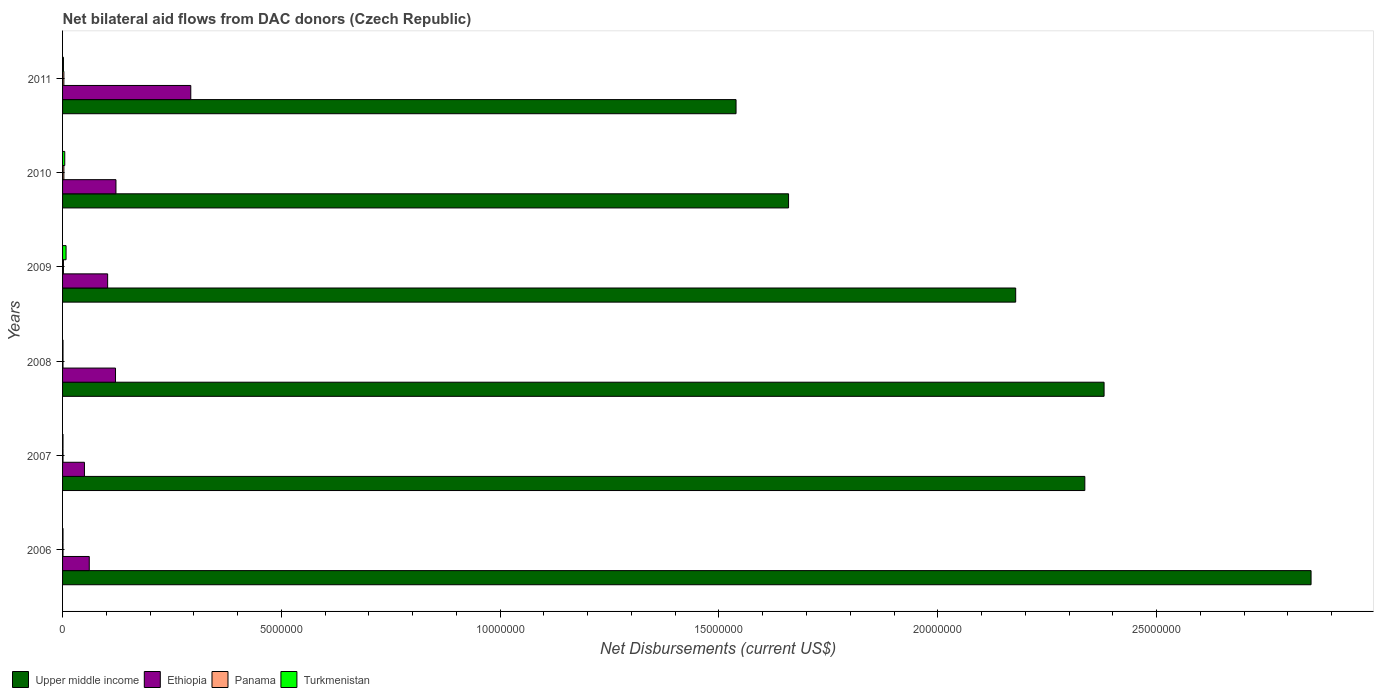How many different coloured bars are there?
Provide a succinct answer. 4. Are the number of bars on each tick of the Y-axis equal?
Ensure brevity in your answer.  Yes. How many bars are there on the 5th tick from the bottom?
Provide a succinct answer. 4. What is the label of the 3rd group of bars from the top?
Your response must be concise. 2009. In how many cases, is the number of bars for a given year not equal to the number of legend labels?
Provide a succinct answer. 0. What is the net bilateral aid flows in Upper middle income in 2011?
Provide a short and direct response. 1.54e+07. Across all years, what is the maximum net bilateral aid flows in Upper middle income?
Your answer should be compact. 2.85e+07. Across all years, what is the minimum net bilateral aid flows in Upper middle income?
Your answer should be compact. 1.54e+07. In which year was the net bilateral aid flows in Ethiopia maximum?
Provide a short and direct response. 2011. What is the total net bilateral aid flows in Ethiopia in the graph?
Give a very brief answer. 7.50e+06. What is the difference between the net bilateral aid flows in Turkmenistan in 2008 and the net bilateral aid flows in Upper middle income in 2007?
Your answer should be very brief. -2.34e+07. What is the average net bilateral aid flows in Upper middle income per year?
Make the answer very short. 2.16e+07. In the year 2006, what is the difference between the net bilateral aid flows in Turkmenistan and net bilateral aid flows in Ethiopia?
Your response must be concise. -6.00e+05. What is the ratio of the net bilateral aid flows in Panama in 2007 to that in 2008?
Your response must be concise. 1. Is the net bilateral aid flows in Upper middle income in 2009 less than that in 2010?
Ensure brevity in your answer.  No. Is the difference between the net bilateral aid flows in Turkmenistan in 2007 and 2011 greater than the difference between the net bilateral aid flows in Ethiopia in 2007 and 2011?
Your response must be concise. Yes. What is the difference between the highest and the second highest net bilateral aid flows in Turkmenistan?
Your response must be concise. 3.00e+04. What is the difference between the highest and the lowest net bilateral aid flows in Ethiopia?
Provide a short and direct response. 2.43e+06. In how many years, is the net bilateral aid flows in Upper middle income greater than the average net bilateral aid flows in Upper middle income taken over all years?
Offer a very short reply. 4. What does the 3rd bar from the top in 2009 represents?
Offer a very short reply. Ethiopia. What does the 1st bar from the bottom in 2009 represents?
Provide a succinct answer. Upper middle income. Is it the case that in every year, the sum of the net bilateral aid flows in Upper middle income and net bilateral aid flows in Panama is greater than the net bilateral aid flows in Turkmenistan?
Keep it short and to the point. Yes. Are all the bars in the graph horizontal?
Ensure brevity in your answer.  Yes. What is the difference between two consecutive major ticks on the X-axis?
Your response must be concise. 5.00e+06. Does the graph contain grids?
Your response must be concise. No. Where does the legend appear in the graph?
Provide a succinct answer. Bottom left. How many legend labels are there?
Offer a terse response. 4. What is the title of the graph?
Your response must be concise. Net bilateral aid flows from DAC donors (Czech Republic). Does "Bahamas" appear as one of the legend labels in the graph?
Give a very brief answer. No. What is the label or title of the X-axis?
Make the answer very short. Net Disbursements (current US$). What is the Net Disbursements (current US$) of Upper middle income in 2006?
Your answer should be compact. 2.85e+07. What is the Net Disbursements (current US$) of Ethiopia in 2006?
Keep it short and to the point. 6.10e+05. What is the Net Disbursements (current US$) of Upper middle income in 2007?
Your response must be concise. 2.34e+07. What is the Net Disbursements (current US$) of Ethiopia in 2007?
Offer a very short reply. 5.00e+05. What is the Net Disbursements (current US$) in Panama in 2007?
Give a very brief answer. 10000. What is the Net Disbursements (current US$) of Turkmenistan in 2007?
Offer a terse response. 10000. What is the Net Disbursements (current US$) of Upper middle income in 2008?
Make the answer very short. 2.38e+07. What is the Net Disbursements (current US$) in Ethiopia in 2008?
Ensure brevity in your answer.  1.21e+06. What is the Net Disbursements (current US$) in Panama in 2008?
Your response must be concise. 10000. What is the Net Disbursements (current US$) of Upper middle income in 2009?
Make the answer very short. 2.18e+07. What is the Net Disbursements (current US$) of Ethiopia in 2009?
Provide a short and direct response. 1.03e+06. What is the Net Disbursements (current US$) of Panama in 2009?
Your answer should be very brief. 2.00e+04. What is the Net Disbursements (current US$) of Upper middle income in 2010?
Provide a short and direct response. 1.66e+07. What is the Net Disbursements (current US$) in Ethiopia in 2010?
Make the answer very short. 1.22e+06. What is the Net Disbursements (current US$) of Turkmenistan in 2010?
Ensure brevity in your answer.  5.00e+04. What is the Net Disbursements (current US$) of Upper middle income in 2011?
Your answer should be very brief. 1.54e+07. What is the Net Disbursements (current US$) of Ethiopia in 2011?
Make the answer very short. 2.93e+06. Across all years, what is the maximum Net Disbursements (current US$) in Upper middle income?
Your answer should be very brief. 2.85e+07. Across all years, what is the maximum Net Disbursements (current US$) of Ethiopia?
Your answer should be very brief. 2.93e+06. Across all years, what is the maximum Net Disbursements (current US$) of Turkmenistan?
Your answer should be very brief. 8.00e+04. Across all years, what is the minimum Net Disbursements (current US$) of Upper middle income?
Your response must be concise. 1.54e+07. Across all years, what is the minimum Net Disbursements (current US$) of Turkmenistan?
Offer a very short reply. 10000. What is the total Net Disbursements (current US$) in Upper middle income in the graph?
Provide a succinct answer. 1.29e+08. What is the total Net Disbursements (current US$) of Ethiopia in the graph?
Provide a succinct answer. 7.50e+06. What is the total Net Disbursements (current US$) of Panama in the graph?
Ensure brevity in your answer.  1.10e+05. What is the total Net Disbursements (current US$) of Turkmenistan in the graph?
Your answer should be very brief. 1.80e+05. What is the difference between the Net Disbursements (current US$) in Upper middle income in 2006 and that in 2007?
Ensure brevity in your answer.  5.17e+06. What is the difference between the Net Disbursements (current US$) of Ethiopia in 2006 and that in 2007?
Offer a very short reply. 1.10e+05. What is the difference between the Net Disbursements (current US$) in Panama in 2006 and that in 2007?
Provide a short and direct response. 0. What is the difference between the Net Disbursements (current US$) of Turkmenistan in 2006 and that in 2007?
Provide a short and direct response. 0. What is the difference between the Net Disbursements (current US$) of Upper middle income in 2006 and that in 2008?
Ensure brevity in your answer.  4.73e+06. What is the difference between the Net Disbursements (current US$) of Ethiopia in 2006 and that in 2008?
Give a very brief answer. -6.00e+05. What is the difference between the Net Disbursements (current US$) in Turkmenistan in 2006 and that in 2008?
Keep it short and to the point. 0. What is the difference between the Net Disbursements (current US$) of Upper middle income in 2006 and that in 2009?
Keep it short and to the point. 6.75e+06. What is the difference between the Net Disbursements (current US$) of Ethiopia in 2006 and that in 2009?
Offer a terse response. -4.20e+05. What is the difference between the Net Disbursements (current US$) in Upper middle income in 2006 and that in 2010?
Offer a very short reply. 1.19e+07. What is the difference between the Net Disbursements (current US$) in Ethiopia in 2006 and that in 2010?
Provide a short and direct response. -6.10e+05. What is the difference between the Net Disbursements (current US$) in Panama in 2006 and that in 2010?
Keep it short and to the point. -2.00e+04. What is the difference between the Net Disbursements (current US$) of Turkmenistan in 2006 and that in 2010?
Your answer should be compact. -4.00e+04. What is the difference between the Net Disbursements (current US$) of Upper middle income in 2006 and that in 2011?
Offer a very short reply. 1.31e+07. What is the difference between the Net Disbursements (current US$) of Ethiopia in 2006 and that in 2011?
Provide a succinct answer. -2.32e+06. What is the difference between the Net Disbursements (current US$) in Upper middle income in 2007 and that in 2008?
Your response must be concise. -4.40e+05. What is the difference between the Net Disbursements (current US$) in Ethiopia in 2007 and that in 2008?
Your answer should be very brief. -7.10e+05. What is the difference between the Net Disbursements (current US$) of Panama in 2007 and that in 2008?
Give a very brief answer. 0. What is the difference between the Net Disbursements (current US$) in Turkmenistan in 2007 and that in 2008?
Your response must be concise. 0. What is the difference between the Net Disbursements (current US$) of Upper middle income in 2007 and that in 2009?
Offer a terse response. 1.58e+06. What is the difference between the Net Disbursements (current US$) of Ethiopia in 2007 and that in 2009?
Provide a succinct answer. -5.30e+05. What is the difference between the Net Disbursements (current US$) in Upper middle income in 2007 and that in 2010?
Offer a terse response. 6.77e+06. What is the difference between the Net Disbursements (current US$) of Ethiopia in 2007 and that in 2010?
Provide a short and direct response. -7.20e+05. What is the difference between the Net Disbursements (current US$) of Turkmenistan in 2007 and that in 2010?
Make the answer very short. -4.00e+04. What is the difference between the Net Disbursements (current US$) in Upper middle income in 2007 and that in 2011?
Your answer should be very brief. 7.97e+06. What is the difference between the Net Disbursements (current US$) in Ethiopia in 2007 and that in 2011?
Offer a terse response. -2.43e+06. What is the difference between the Net Disbursements (current US$) in Turkmenistan in 2007 and that in 2011?
Your answer should be very brief. -10000. What is the difference between the Net Disbursements (current US$) of Upper middle income in 2008 and that in 2009?
Ensure brevity in your answer.  2.02e+06. What is the difference between the Net Disbursements (current US$) of Panama in 2008 and that in 2009?
Keep it short and to the point. -10000. What is the difference between the Net Disbursements (current US$) in Turkmenistan in 2008 and that in 2009?
Make the answer very short. -7.00e+04. What is the difference between the Net Disbursements (current US$) of Upper middle income in 2008 and that in 2010?
Your response must be concise. 7.21e+06. What is the difference between the Net Disbursements (current US$) in Panama in 2008 and that in 2010?
Ensure brevity in your answer.  -2.00e+04. What is the difference between the Net Disbursements (current US$) of Turkmenistan in 2008 and that in 2010?
Provide a short and direct response. -4.00e+04. What is the difference between the Net Disbursements (current US$) in Upper middle income in 2008 and that in 2011?
Provide a succinct answer. 8.41e+06. What is the difference between the Net Disbursements (current US$) in Ethiopia in 2008 and that in 2011?
Keep it short and to the point. -1.72e+06. What is the difference between the Net Disbursements (current US$) of Turkmenistan in 2008 and that in 2011?
Your answer should be compact. -10000. What is the difference between the Net Disbursements (current US$) of Upper middle income in 2009 and that in 2010?
Make the answer very short. 5.19e+06. What is the difference between the Net Disbursements (current US$) of Ethiopia in 2009 and that in 2010?
Keep it short and to the point. -1.90e+05. What is the difference between the Net Disbursements (current US$) in Panama in 2009 and that in 2010?
Keep it short and to the point. -10000. What is the difference between the Net Disbursements (current US$) of Turkmenistan in 2009 and that in 2010?
Your answer should be compact. 3.00e+04. What is the difference between the Net Disbursements (current US$) in Upper middle income in 2009 and that in 2011?
Ensure brevity in your answer.  6.39e+06. What is the difference between the Net Disbursements (current US$) in Ethiopia in 2009 and that in 2011?
Offer a very short reply. -1.90e+06. What is the difference between the Net Disbursements (current US$) in Turkmenistan in 2009 and that in 2011?
Your response must be concise. 6.00e+04. What is the difference between the Net Disbursements (current US$) of Upper middle income in 2010 and that in 2011?
Ensure brevity in your answer.  1.20e+06. What is the difference between the Net Disbursements (current US$) of Ethiopia in 2010 and that in 2011?
Your response must be concise. -1.71e+06. What is the difference between the Net Disbursements (current US$) of Panama in 2010 and that in 2011?
Offer a terse response. 0. What is the difference between the Net Disbursements (current US$) of Turkmenistan in 2010 and that in 2011?
Provide a succinct answer. 3.00e+04. What is the difference between the Net Disbursements (current US$) in Upper middle income in 2006 and the Net Disbursements (current US$) in Ethiopia in 2007?
Provide a short and direct response. 2.80e+07. What is the difference between the Net Disbursements (current US$) in Upper middle income in 2006 and the Net Disbursements (current US$) in Panama in 2007?
Your response must be concise. 2.85e+07. What is the difference between the Net Disbursements (current US$) in Upper middle income in 2006 and the Net Disbursements (current US$) in Turkmenistan in 2007?
Ensure brevity in your answer.  2.85e+07. What is the difference between the Net Disbursements (current US$) in Ethiopia in 2006 and the Net Disbursements (current US$) in Turkmenistan in 2007?
Offer a terse response. 6.00e+05. What is the difference between the Net Disbursements (current US$) of Panama in 2006 and the Net Disbursements (current US$) of Turkmenistan in 2007?
Your answer should be very brief. 0. What is the difference between the Net Disbursements (current US$) in Upper middle income in 2006 and the Net Disbursements (current US$) in Ethiopia in 2008?
Your response must be concise. 2.73e+07. What is the difference between the Net Disbursements (current US$) in Upper middle income in 2006 and the Net Disbursements (current US$) in Panama in 2008?
Offer a very short reply. 2.85e+07. What is the difference between the Net Disbursements (current US$) of Upper middle income in 2006 and the Net Disbursements (current US$) of Turkmenistan in 2008?
Offer a terse response. 2.85e+07. What is the difference between the Net Disbursements (current US$) in Ethiopia in 2006 and the Net Disbursements (current US$) in Panama in 2008?
Your response must be concise. 6.00e+05. What is the difference between the Net Disbursements (current US$) of Ethiopia in 2006 and the Net Disbursements (current US$) of Turkmenistan in 2008?
Give a very brief answer. 6.00e+05. What is the difference between the Net Disbursements (current US$) in Upper middle income in 2006 and the Net Disbursements (current US$) in Ethiopia in 2009?
Your answer should be very brief. 2.75e+07. What is the difference between the Net Disbursements (current US$) in Upper middle income in 2006 and the Net Disbursements (current US$) in Panama in 2009?
Provide a short and direct response. 2.85e+07. What is the difference between the Net Disbursements (current US$) in Upper middle income in 2006 and the Net Disbursements (current US$) in Turkmenistan in 2009?
Make the answer very short. 2.84e+07. What is the difference between the Net Disbursements (current US$) in Ethiopia in 2006 and the Net Disbursements (current US$) in Panama in 2009?
Provide a succinct answer. 5.90e+05. What is the difference between the Net Disbursements (current US$) in Ethiopia in 2006 and the Net Disbursements (current US$) in Turkmenistan in 2009?
Your answer should be very brief. 5.30e+05. What is the difference between the Net Disbursements (current US$) in Panama in 2006 and the Net Disbursements (current US$) in Turkmenistan in 2009?
Offer a terse response. -7.00e+04. What is the difference between the Net Disbursements (current US$) in Upper middle income in 2006 and the Net Disbursements (current US$) in Ethiopia in 2010?
Provide a succinct answer. 2.73e+07. What is the difference between the Net Disbursements (current US$) in Upper middle income in 2006 and the Net Disbursements (current US$) in Panama in 2010?
Ensure brevity in your answer.  2.85e+07. What is the difference between the Net Disbursements (current US$) in Upper middle income in 2006 and the Net Disbursements (current US$) in Turkmenistan in 2010?
Keep it short and to the point. 2.85e+07. What is the difference between the Net Disbursements (current US$) in Ethiopia in 2006 and the Net Disbursements (current US$) in Panama in 2010?
Your answer should be very brief. 5.80e+05. What is the difference between the Net Disbursements (current US$) of Ethiopia in 2006 and the Net Disbursements (current US$) of Turkmenistan in 2010?
Give a very brief answer. 5.60e+05. What is the difference between the Net Disbursements (current US$) in Panama in 2006 and the Net Disbursements (current US$) in Turkmenistan in 2010?
Provide a short and direct response. -4.00e+04. What is the difference between the Net Disbursements (current US$) in Upper middle income in 2006 and the Net Disbursements (current US$) in Ethiopia in 2011?
Make the answer very short. 2.56e+07. What is the difference between the Net Disbursements (current US$) in Upper middle income in 2006 and the Net Disbursements (current US$) in Panama in 2011?
Keep it short and to the point. 2.85e+07. What is the difference between the Net Disbursements (current US$) of Upper middle income in 2006 and the Net Disbursements (current US$) of Turkmenistan in 2011?
Keep it short and to the point. 2.85e+07. What is the difference between the Net Disbursements (current US$) in Ethiopia in 2006 and the Net Disbursements (current US$) in Panama in 2011?
Make the answer very short. 5.80e+05. What is the difference between the Net Disbursements (current US$) in Ethiopia in 2006 and the Net Disbursements (current US$) in Turkmenistan in 2011?
Make the answer very short. 5.90e+05. What is the difference between the Net Disbursements (current US$) in Panama in 2006 and the Net Disbursements (current US$) in Turkmenistan in 2011?
Give a very brief answer. -10000. What is the difference between the Net Disbursements (current US$) in Upper middle income in 2007 and the Net Disbursements (current US$) in Ethiopia in 2008?
Provide a succinct answer. 2.22e+07. What is the difference between the Net Disbursements (current US$) of Upper middle income in 2007 and the Net Disbursements (current US$) of Panama in 2008?
Your response must be concise. 2.34e+07. What is the difference between the Net Disbursements (current US$) of Upper middle income in 2007 and the Net Disbursements (current US$) of Turkmenistan in 2008?
Provide a succinct answer. 2.34e+07. What is the difference between the Net Disbursements (current US$) of Panama in 2007 and the Net Disbursements (current US$) of Turkmenistan in 2008?
Provide a succinct answer. 0. What is the difference between the Net Disbursements (current US$) in Upper middle income in 2007 and the Net Disbursements (current US$) in Ethiopia in 2009?
Your answer should be compact. 2.23e+07. What is the difference between the Net Disbursements (current US$) of Upper middle income in 2007 and the Net Disbursements (current US$) of Panama in 2009?
Offer a very short reply. 2.33e+07. What is the difference between the Net Disbursements (current US$) in Upper middle income in 2007 and the Net Disbursements (current US$) in Turkmenistan in 2009?
Your answer should be compact. 2.33e+07. What is the difference between the Net Disbursements (current US$) in Ethiopia in 2007 and the Net Disbursements (current US$) in Panama in 2009?
Make the answer very short. 4.80e+05. What is the difference between the Net Disbursements (current US$) in Upper middle income in 2007 and the Net Disbursements (current US$) in Ethiopia in 2010?
Your answer should be very brief. 2.21e+07. What is the difference between the Net Disbursements (current US$) of Upper middle income in 2007 and the Net Disbursements (current US$) of Panama in 2010?
Provide a succinct answer. 2.33e+07. What is the difference between the Net Disbursements (current US$) in Upper middle income in 2007 and the Net Disbursements (current US$) in Turkmenistan in 2010?
Your response must be concise. 2.33e+07. What is the difference between the Net Disbursements (current US$) in Ethiopia in 2007 and the Net Disbursements (current US$) in Turkmenistan in 2010?
Your response must be concise. 4.50e+05. What is the difference between the Net Disbursements (current US$) of Upper middle income in 2007 and the Net Disbursements (current US$) of Ethiopia in 2011?
Provide a succinct answer. 2.04e+07. What is the difference between the Net Disbursements (current US$) in Upper middle income in 2007 and the Net Disbursements (current US$) in Panama in 2011?
Ensure brevity in your answer.  2.33e+07. What is the difference between the Net Disbursements (current US$) in Upper middle income in 2007 and the Net Disbursements (current US$) in Turkmenistan in 2011?
Your answer should be very brief. 2.33e+07. What is the difference between the Net Disbursements (current US$) of Ethiopia in 2007 and the Net Disbursements (current US$) of Panama in 2011?
Make the answer very short. 4.70e+05. What is the difference between the Net Disbursements (current US$) in Upper middle income in 2008 and the Net Disbursements (current US$) in Ethiopia in 2009?
Your response must be concise. 2.28e+07. What is the difference between the Net Disbursements (current US$) of Upper middle income in 2008 and the Net Disbursements (current US$) of Panama in 2009?
Make the answer very short. 2.38e+07. What is the difference between the Net Disbursements (current US$) of Upper middle income in 2008 and the Net Disbursements (current US$) of Turkmenistan in 2009?
Provide a short and direct response. 2.37e+07. What is the difference between the Net Disbursements (current US$) of Ethiopia in 2008 and the Net Disbursements (current US$) of Panama in 2009?
Your answer should be very brief. 1.19e+06. What is the difference between the Net Disbursements (current US$) of Ethiopia in 2008 and the Net Disbursements (current US$) of Turkmenistan in 2009?
Provide a short and direct response. 1.13e+06. What is the difference between the Net Disbursements (current US$) in Panama in 2008 and the Net Disbursements (current US$) in Turkmenistan in 2009?
Your response must be concise. -7.00e+04. What is the difference between the Net Disbursements (current US$) of Upper middle income in 2008 and the Net Disbursements (current US$) of Ethiopia in 2010?
Keep it short and to the point. 2.26e+07. What is the difference between the Net Disbursements (current US$) in Upper middle income in 2008 and the Net Disbursements (current US$) in Panama in 2010?
Your answer should be compact. 2.38e+07. What is the difference between the Net Disbursements (current US$) in Upper middle income in 2008 and the Net Disbursements (current US$) in Turkmenistan in 2010?
Make the answer very short. 2.38e+07. What is the difference between the Net Disbursements (current US$) of Ethiopia in 2008 and the Net Disbursements (current US$) of Panama in 2010?
Keep it short and to the point. 1.18e+06. What is the difference between the Net Disbursements (current US$) in Ethiopia in 2008 and the Net Disbursements (current US$) in Turkmenistan in 2010?
Offer a terse response. 1.16e+06. What is the difference between the Net Disbursements (current US$) in Upper middle income in 2008 and the Net Disbursements (current US$) in Ethiopia in 2011?
Your response must be concise. 2.09e+07. What is the difference between the Net Disbursements (current US$) of Upper middle income in 2008 and the Net Disbursements (current US$) of Panama in 2011?
Offer a very short reply. 2.38e+07. What is the difference between the Net Disbursements (current US$) of Upper middle income in 2008 and the Net Disbursements (current US$) of Turkmenistan in 2011?
Your response must be concise. 2.38e+07. What is the difference between the Net Disbursements (current US$) of Ethiopia in 2008 and the Net Disbursements (current US$) of Panama in 2011?
Ensure brevity in your answer.  1.18e+06. What is the difference between the Net Disbursements (current US$) in Ethiopia in 2008 and the Net Disbursements (current US$) in Turkmenistan in 2011?
Ensure brevity in your answer.  1.19e+06. What is the difference between the Net Disbursements (current US$) of Upper middle income in 2009 and the Net Disbursements (current US$) of Ethiopia in 2010?
Provide a succinct answer. 2.06e+07. What is the difference between the Net Disbursements (current US$) in Upper middle income in 2009 and the Net Disbursements (current US$) in Panama in 2010?
Your response must be concise. 2.18e+07. What is the difference between the Net Disbursements (current US$) in Upper middle income in 2009 and the Net Disbursements (current US$) in Turkmenistan in 2010?
Make the answer very short. 2.17e+07. What is the difference between the Net Disbursements (current US$) of Ethiopia in 2009 and the Net Disbursements (current US$) of Turkmenistan in 2010?
Make the answer very short. 9.80e+05. What is the difference between the Net Disbursements (current US$) in Panama in 2009 and the Net Disbursements (current US$) in Turkmenistan in 2010?
Make the answer very short. -3.00e+04. What is the difference between the Net Disbursements (current US$) in Upper middle income in 2009 and the Net Disbursements (current US$) in Ethiopia in 2011?
Offer a terse response. 1.88e+07. What is the difference between the Net Disbursements (current US$) of Upper middle income in 2009 and the Net Disbursements (current US$) of Panama in 2011?
Offer a terse response. 2.18e+07. What is the difference between the Net Disbursements (current US$) in Upper middle income in 2009 and the Net Disbursements (current US$) in Turkmenistan in 2011?
Make the answer very short. 2.18e+07. What is the difference between the Net Disbursements (current US$) of Ethiopia in 2009 and the Net Disbursements (current US$) of Turkmenistan in 2011?
Offer a terse response. 1.01e+06. What is the difference between the Net Disbursements (current US$) of Panama in 2009 and the Net Disbursements (current US$) of Turkmenistan in 2011?
Provide a short and direct response. 0. What is the difference between the Net Disbursements (current US$) of Upper middle income in 2010 and the Net Disbursements (current US$) of Ethiopia in 2011?
Make the answer very short. 1.37e+07. What is the difference between the Net Disbursements (current US$) in Upper middle income in 2010 and the Net Disbursements (current US$) in Panama in 2011?
Make the answer very short. 1.66e+07. What is the difference between the Net Disbursements (current US$) of Upper middle income in 2010 and the Net Disbursements (current US$) of Turkmenistan in 2011?
Your answer should be very brief. 1.66e+07. What is the difference between the Net Disbursements (current US$) in Ethiopia in 2010 and the Net Disbursements (current US$) in Panama in 2011?
Offer a terse response. 1.19e+06. What is the difference between the Net Disbursements (current US$) in Ethiopia in 2010 and the Net Disbursements (current US$) in Turkmenistan in 2011?
Provide a succinct answer. 1.20e+06. What is the average Net Disbursements (current US$) in Upper middle income per year?
Offer a terse response. 2.16e+07. What is the average Net Disbursements (current US$) of Ethiopia per year?
Make the answer very short. 1.25e+06. What is the average Net Disbursements (current US$) of Panama per year?
Make the answer very short. 1.83e+04. In the year 2006, what is the difference between the Net Disbursements (current US$) in Upper middle income and Net Disbursements (current US$) in Ethiopia?
Your answer should be compact. 2.79e+07. In the year 2006, what is the difference between the Net Disbursements (current US$) of Upper middle income and Net Disbursements (current US$) of Panama?
Keep it short and to the point. 2.85e+07. In the year 2006, what is the difference between the Net Disbursements (current US$) of Upper middle income and Net Disbursements (current US$) of Turkmenistan?
Offer a very short reply. 2.85e+07. In the year 2006, what is the difference between the Net Disbursements (current US$) of Ethiopia and Net Disbursements (current US$) of Panama?
Provide a short and direct response. 6.00e+05. In the year 2006, what is the difference between the Net Disbursements (current US$) of Panama and Net Disbursements (current US$) of Turkmenistan?
Provide a succinct answer. 0. In the year 2007, what is the difference between the Net Disbursements (current US$) in Upper middle income and Net Disbursements (current US$) in Ethiopia?
Ensure brevity in your answer.  2.29e+07. In the year 2007, what is the difference between the Net Disbursements (current US$) in Upper middle income and Net Disbursements (current US$) in Panama?
Your answer should be compact. 2.34e+07. In the year 2007, what is the difference between the Net Disbursements (current US$) in Upper middle income and Net Disbursements (current US$) in Turkmenistan?
Your response must be concise. 2.34e+07. In the year 2007, what is the difference between the Net Disbursements (current US$) of Ethiopia and Net Disbursements (current US$) of Panama?
Ensure brevity in your answer.  4.90e+05. In the year 2007, what is the difference between the Net Disbursements (current US$) in Ethiopia and Net Disbursements (current US$) in Turkmenistan?
Make the answer very short. 4.90e+05. In the year 2007, what is the difference between the Net Disbursements (current US$) of Panama and Net Disbursements (current US$) of Turkmenistan?
Your answer should be very brief. 0. In the year 2008, what is the difference between the Net Disbursements (current US$) of Upper middle income and Net Disbursements (current US$) of Ethiopia?
Your response must be concise. 2.26e+07. In the year 2008, what is the difference between the Net Disbursements (current US$) of Upper middle income and Net Disbursements (current US$) of Panama?
Provide a short and direct response. 2.38e+07. In the year 2008, what is the difference between the Net Disbursements (current US$) of Upper middle income and Net Disbursements (current US$) of Turkmenistan?
Keep it short and to the point. 2.38e+07. In the year 2008, what is the difference between the Net Disbursements (current US$) of Ethiopia and Net Disbursements (current US$) of Panama?
Offer a very short reply. 1.20e+06. In the year 2008, what is the difference between the Net Disbursements (current US$) of Ethiopia and Net Disbursements (current US$) of Turkmenistan?
Provide a short and direct response. 1.20e+06. In the year 2009, what is the difference between the Net Disbursements (current US$) of Upper middle income and Net Disbursements (current US$) of Ethiopia?
Provide a succinct answer. 2.08e+07. In the year 2009, what is the difference between the Net Disbursements (current US$) in Upper middle income and Net Disbursements (current US$) in Panama?
Your answer should be very brief. 2.18e+07. In the year 2009, what is the difference between the Net Disbursements (current US$) in Upper middle income and Net Disbursements (current US$) in Turkmenistan?
Make the answer very short. 2.17e+07. In the year 2009, what is the difference between the Net Disbursements (current US$) in Ethiopia and Net Disbursements (current US$) in Panama?
Keep it short and to the point. 1.01e+06. In the year 2009, what is the difference between the Net Disbursements (current US$) in Ethiopia and Net Disbursements (current US$) in Turkmenistan?
Offer a very short reply. 9.50e+05. In the year 2010, what is the difference between the Net Disbursements (current US$) of Upper middle income and Net Disbursements (current US$) of Ethiopia?
Provide a short and direct response. 1.54e+07. In the year 2010, what is the difference between the Net Disbursements (current US$) in Upper middle income and Net Disbursements (current US$) in Panama?
Give a very brief answer. 1.66e+07. In the year 2010, what is the difference between the Net Disbursements (current US$) in Upper middle income and Net Disbursements (current US$) in Turkmenistan?
Provide a short and direct response. 1.65e+07. In the year 2010, what is the difference between the Net Disbursements (current US$) of Ethiopia and Net Disbursements (current US$) of Panama?
Your response must be concise. 1.19e+06. In the year 2010, what is the difference between the Net Disbursements (current US$) of Ethiopia and Net Disbursements (current US$) of Turkmenistan?
Your response must be concise. 1.17e+06. In the year 2011, what is the difference between the Net Disbursements (current US$) of Upper middle income and Net Disbursements (current US$) of Ethiopia?
Keep it short and to the point. 1.25e+07. In the year 2011, what is the difference between the Net Disbursements (current US$) in Upper middle income and Net Disbursements (current US$) in Panama?
Provide a short and direct response. 1.54e+07. In the year 2011, what is the difference between the Net Disbursements (current US$) in Upper middle income and Net Disbursements (current US$) in Turkmenistan?
Keep it short and to the point. 1.54e+07. In the year 2011, what is the difference between the Net Disbursements (current US$) in Ethiopia and Net Disbursements (current US$) in Panama?
Your answer should be compact. 2.90e+06. In the year 2011, what is the difference between the Net Disbursements (current US$) of Ethiopia and Net Disbursements (current US$) of Turkmenistan?
Keep it short and to the point. 2.91e+06. What is the ratio of the Net Disbursements (current US$) in Upper middle income in 2006 to that in 2007?
Your answer should be compact. 1.22. What is the ratio of the Net Disbursements (current US$) in Ethiopia in 2006 to that in 2007?
Provide a succinct answer. 1.22. What is the ratio of the Net Disbursements (current US$) of Panama in 2006 to that in 2007?
Give a very brief answer. 1. What is the ratio of the Net Disbursements (current US$) in Upper middle income in 2006 to that in 2008?
Ensure brevity in your answer.  1.2. What is the ratio of the Net Disbursements (current US$) of Ethiopia in 2006 to that in 2008?
Make the answer very short. 0.5. What is the ratio of the Net Disbursements (current US$) in Turkmenistan in 2006 to that in 2008?
Your response must be concise. 1. What is the ratio of the Net Disbursements (current US$) in Upper middle income in 2006 to that in 2009?
Your response must be concise. 1.31. What is the ratio of the Net Disbursements (current US$) of Ethiopia in 2006 to that in 2009?
Your response must be concise. 0.59. What is the ratio of the Net Disbursements (current US$) of Panama in 2006 to that in 2009?
Keep it short and to the point. 0.5. What is the ratio of the Net Disbursements (current US$) of Upper middle income in 2006 to that in 2010?
Provide a succinct answer. 1.72. What is the ratio of the Net Disbursements (current US$) in Ethiopia in 2006 to that in 2010?
Your answer should be compact. 0.5. What is the ratio of the Net Disbursements (current US$) of Upper middle income in 2006 to that in 2011?
Your answer should be compact. 1.85. What is the ratio of the Net Disbursements (current US$) of Ethiopia in 2006 to that in 2011?
Provide a short and direct response. 0.21. What is the ratio of the Net Disbursements (current US$) of Upper middle income in 2007 to that in 2008?
Your answer should be very brief. 0.98. What is the ratio of the Net Disbursements (current US$) of Ethiopia in 2007 to that in 2008?
Make the answer very short. 0.41. What is the ratio of the Net Disbursements (current US$) of Panama in 2007 to that in 2008?
Provide a succinct answer. 1. What is the ratio of the Net Disbursements (current US$) in Turkmenistan in 2007 to that in 2008?
Make the answer very short. 1. What is the ratio of the Net Disbursements (current US$) in Upper middle income in 2007 to that in 2009?
Your response must be concise. 1.07. What is the ratio of the Net Disbursements (current US$) of Ethiopia in 2007 to that in 2009?
Offer a very short reply. 0.49. What is the ratio of the Net Disbursements (current US$) of Panama in 2007 to that in 2009?
Provide a succinct answer. 0.5. What is the ratio of the Net Disbursements (current US$) in Upper middle income in 2007 to that in 2010?
Provide a short and direct response. 1.41. What is the ratio of the Net Disbursements (current US$) in Ethiopia in 2007 to that in 2010?
Provide a succinct answer. 0.41. What is the ratio of the Net Disbursements (current US$) of Panama in 2007 to that in 2010?
Your answer should be very brief. 0.33. What is the ratio of the Net Disbursements (current US$) of Turkmenistan in 2007 to that in 2010?
Provide a short and direct response. 0.2. What is the ratio of the Net Disbursements (current US$) in Upper middle income in 2007 to that in 2011?
Your answer should be compact. 1.52. What is the ratio of the Net Disbursements (current US$) in Ethiopia in 2007 to that in 2011?
Ensure brevity in your answer.  0.17. What is the ratio of the Net Disbursements (current US$) in Panama in 2007 to that in 2011?
Your response must be concise. 0.33. What is the ratio of the Net Disbursements (current US$) of Upper middle income in 2008 to that in 2009?
Your answer should be very brief. 1.09. What is the ratio of the Net Disbursements (current US$) of Ethiopia in 2008 to that in 2009?
Provide a succinct answer. 1.17. What is the ratio of the Net Disbursements (current US$) in Panama in 2008 to that in 2009?
Give a very brief answer. 0.5. What is the ratio of the Net Disbursements (current US$) in Upper middle income in 2008 to that in 2010?
Provide a succinct answer. 1.43. What is the ratio of the Net Disbursements (current US$) of Panama in 2008 to that in 2010?
Your answer should be compact. 0.33. What is the ratio of the Net Disbursements (current US$) of Upper middle income in 2008 to that in 2011?
Give a very brief answer. 1.55. What is the ratio of the Net Disbursements (current US$) in Ethiopia in 2008 to that in 2011?
Ensure brevity in your answer.  0.41. What is the ratio of the Net Disbursements (current US$) in Panama in 2008 to that in 2011?
Your response must be concise. 0.33. What is the ratio of the Net Disbursements (current US$) in Turkmenistan in 2008 to that in 2011?
Ensure brevity in your answer.  0.5. What is the ratio of the Net Disbursements (current US$) of Upper middle income in 2009 to that in 2010?
Offer a very short reply. 1.31. What is the ratio of the Net Disbursements (current US$) of Ethiopia in 2009 to that in 2010?
Give a very brief answer. 0.84. What is the ratio of the Net Disbursements (current US$) of Panama in 2009 to that in 2010?
Your answer should be compact. 0.67. What is the ratio of the Net Disbursements (current US$) of Upper middle income in 2009 to that in 2011?
Give a very brief answer. 1.42. What is the ratio of the Net Disbursements (current US$) in Ethiopia in 2009 to that in 2011?
Offer a very short reply. 0.35. What is the ratio of the Net Disbursements (current US$) of Panama in 2009 to that in 2011?
Offer a terse response. 0.67. What is the ratio of the Net Disbursements (current US$) in Turkmenistan in 2009 to that in 2011?
Your answer should be very brief. 4. What is the ratio of the Net Disbursements (current US$) in Upper middle income in 2010 to that in 2011?
Provide a succinct answer. 1.08. What is the ratio of the Net Disbursements (current US$) of Ethiopia in 2010 to that in 2011?
Keep it short and to the point. 0.42. What is the ratio of the Net Disbursements (current US$) in Panama in 2010 to that in 2011?
Provide a succinct answer. 1. What is the ratio of the Net Disbursements (current US$) in Turkmenistan in 2010 to that in 2011?
Provide a short and direct response. 2.5. What is the difference between the highest and the second highest Net Disbursements (current US$) in Upper middle income?
Give a very brief answer. 4.73e+06. What is the difference between the highest and the second highest Net Disbursements (current US$) of Ethiopia?
Your answer should be very brief. 1.71e+06. What is the difference between the highest and the second highest Net Disbursements (current US$) of Panama?
Your answer should be compact. 0. What is the difference between the highest and the lowest Net Disbursements (current US$) in Upper middle income?
Offer a terse response. 1.31e+07. What is the difference between the highest and the lowest Net Disbursements (current US$) of Ethiopia?
Your answer should be very brief. 2.43e+06. What is the difference between the highest and the lowest Net Disbursements (current US$) in Turkmenistan?
Give a very brief answer. 7.00e+04. 